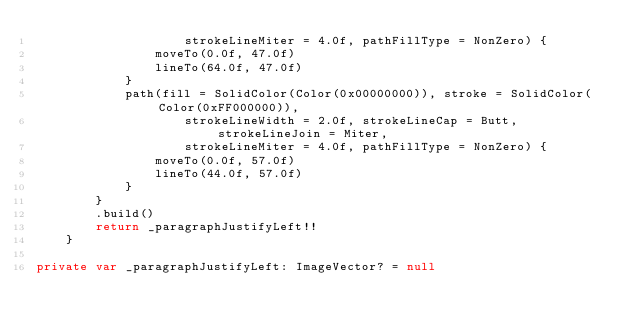Convert code to text. <code><loc_0><loc_0><loc_500><loc_500><_Kotlin_>                    strokeLineMiter = 4.0f, pathFillType = NonZero) {
                moveTo(0.0f, 47.0f)
                lineTo(64.0f, 47.0f)
            }
            path(fill = SolidColor(Color(0x00000000)), stroke = SolidColor(Color(0xFF000000)),
                    strokeLineWidth = 2.0f, strokeLineCap = Butt, strokeLineJoin = Miter,
                    strokeLineMiter = 4.0f, pathFillType = NonZero) {
                moveTo(0.0f, 57.0f)
                lineTo(44.0f, 57.0f)
            }
        }
        .build()
        return _paragraphJustifyLeft!!
    }

private var _paragraphJustifyLeft: ImageVector? = null
</code> 